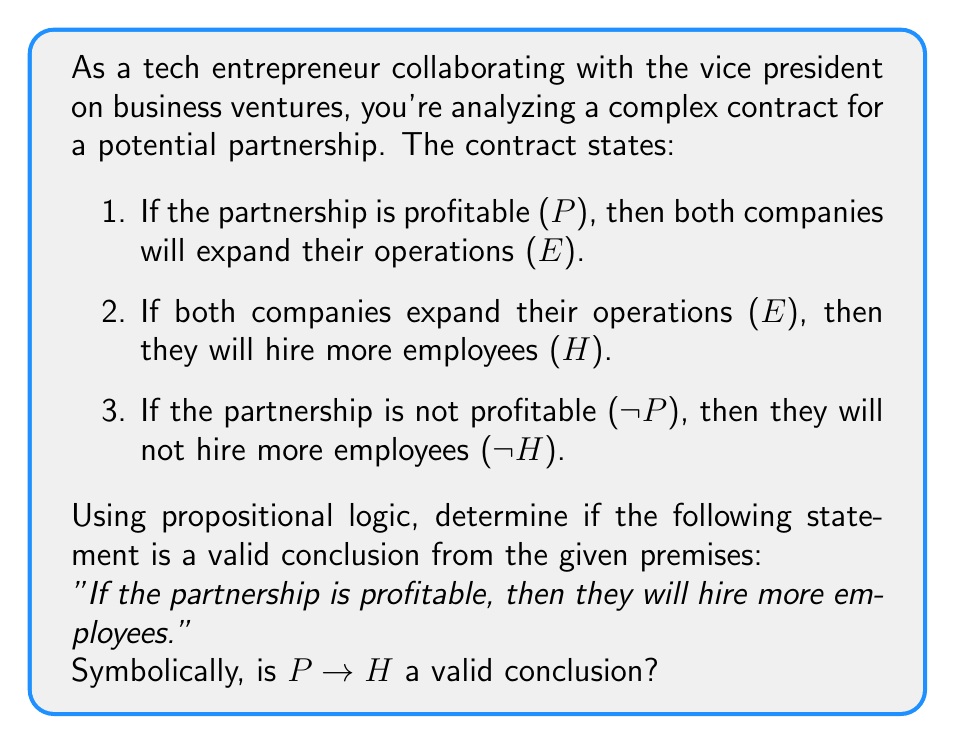Teach me how to tackle this problem. Let's approach this step-by-step using propositional logic:

1. First, let's symbolize the given premises:
   Premise 1: $P \rightarrow E$
   Premise 2: $E \rightarrow H$
   Premise 3: $\neg P \rightarrow \neg H$

2. We want to prove if $P \rightarrow H$ is a valid conclusion.

3. We can use the method of natural deduction:

   $$\begin{aligned}
   1. & P \rightarrow E & \text{(Premise 1)} \\
   2. & E \rightarrow H & \text{(Premise 2)} \\
   3. & P & \text{(Assumption)} \\
   4. & E & \text{(Modus Ponens, 1, 3)} \\
   5. & H & \text{(Modus Ponens, 2, 4)} \\
   \end{aligned}$$

4. From steps 3-5, we've shown that if $P$ is true, then $H$ must be true.

5. This establishes the conditional statement $P \rightarrow H$.

6. Note that we didn't need to use Premise 3 ($\neg P \rightarrow \neg H$) in our proof.

Therefore, $P \rightarrow H$ is indeed a valid conclusion from the given premises.
Answer: Yes, $P \rightarrow H$ is a valid conclusion from the given premises. 